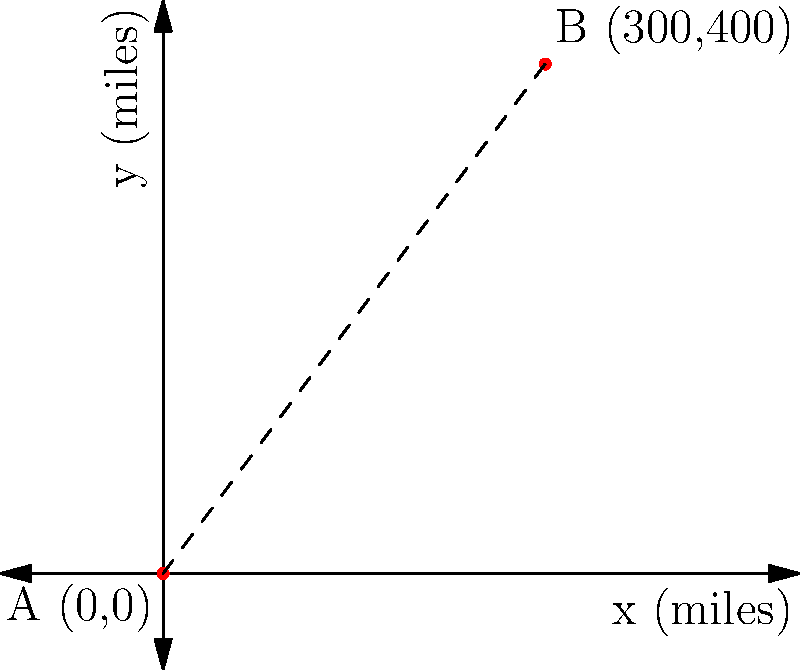On your route map, you need to calculate the direct distance between two refueling stations. Station A is located at coordinates (0,0) and Station B is at (300,400), where each unit represents 1 mile. Using the distance formula, determine the straight-line distance between these two stations. To find the distance between two points, we use the distance formula:

$$ d = \sqrt{(x_2 - x_1)^2 + (y_2 - y_1)^2} $$

Where $(x_1, y_1)$ are the coordinates of the first point and $(x_2, y_2)$ are the coordinates of the second point.

Step 1: Identify the coordinates
- Point A: $(x_1, y_1) = (0, 0)$
- Point B: $(x_2, y_2) = (300, 400)$

Step 2: Plug the values into the formula
$$ d = \sqrt{(300 - 0)^2 + (400 - 0)^2} $$

Step 3: Simplify
$$ d = \sqrt{300^2 + 400^2} $$

Step 4: Calculate
$$ d = \sqrt{90,000 + 160,000} = \sqrt{250,000} = 500 $$

Therefore, the straight-line distance between the two refueling stations is 500 miles.
Answer: 500 miles 